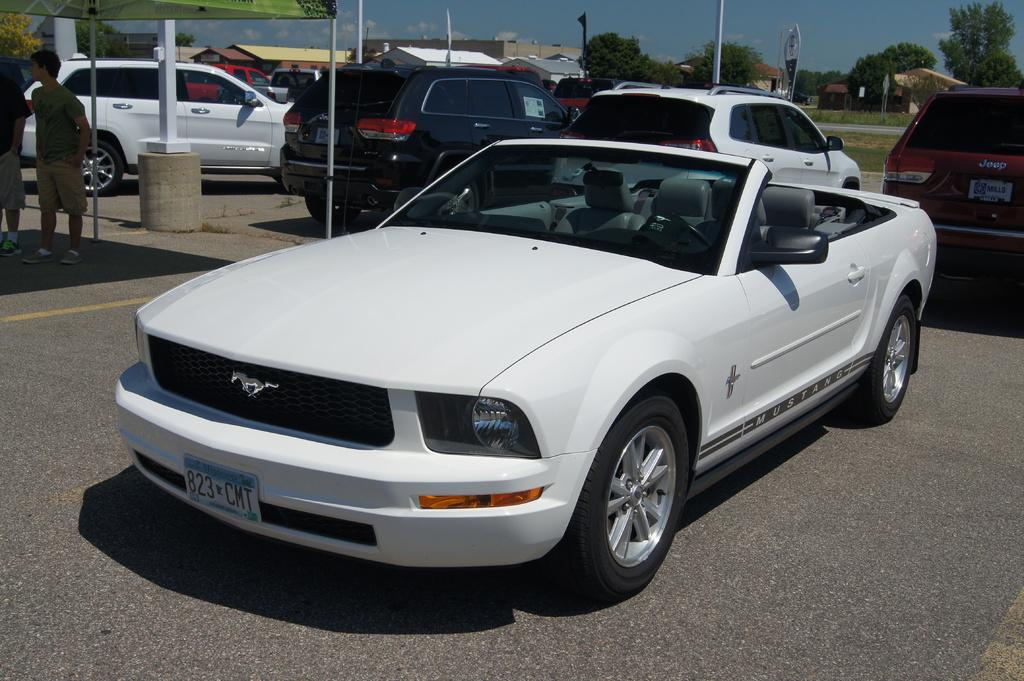How would you summarize this image in a sentence or two? In this picture I can see vehicles on the road, there are two persons standing, there are buildings, trees, there is an umbrella, and in the background there is the sky. 